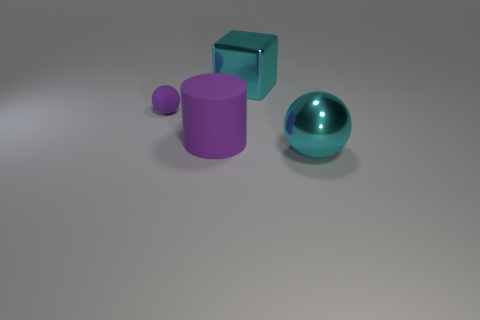There is a tiny sphere that is the same color as the big rubber cylinder; what is it made of?
Offer a very short reply. Rubber. How many large purple objects have the same material as the large cyan sphere?
Provide a short and direct response. 0. Is the number of large cubes to the right of the large metallic ball less than the number of big purple matte cylinders that are to the right of the big purple matte object?
Provide a short and direct response. No. What is the sphere that is left of the cyan thing behind the big cyan metal thing that is in front of the tiny rubber ball made of?
Provide a succinct answer. Rubber. What size is the thing that is both on the right side of the purple ball and behind the purple cylinder?
Provide a short and direct response. Large. What number of cubes are either rubber objects or big things?
Provide a succinct answer. 1. There is a matte cylinder that is the same size as the cyan sphere; what is its color?
Offer a very short reply. Purple. Is there anything else that has the same shape as the big purple object?
Provide a succinct answer. No. What is the color of the big metallic object that is the same shape as the small purple thing?
Give a very brief answer. Cyan. How many things are large gray matte blocks or metal objects that are to the left of the large shiny sphere?
Ensure brevity in your answer.  1. 